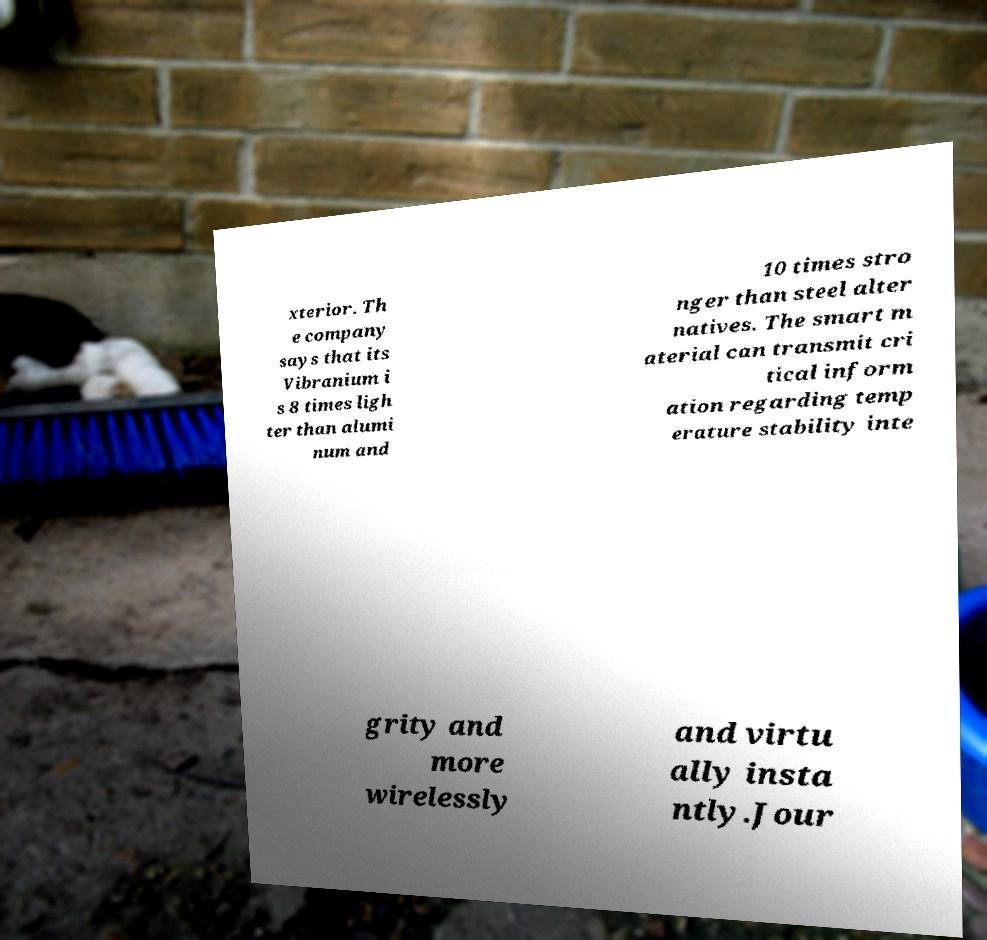Please read and relay the text visible in this image. What does it say? xterior. Th e company says that its Vibranium i s 8 times ligh ter than alumi num and 10 times stro nger than steel alter natives. The smart m aterial can transmit cri tical inform ation regarding temp erature stability inte grity and more wirelessly and virtu ally insta ntly.Jour 